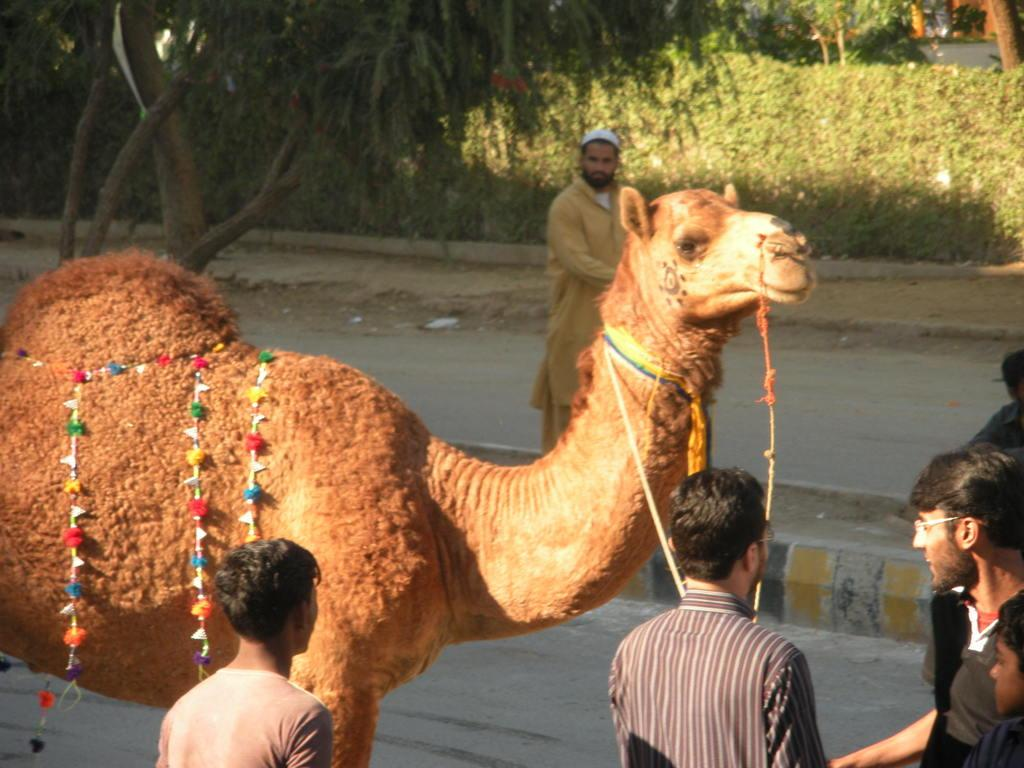What animal is present in the image? There is a camel in the image. What color is the camel? The camel is brown. Who else is in the image besides the camel? There is a group of people in the image. What can be observed about the people's clothing? The people are wearing different color dresses. What can be seen in the background of the image? There are many trees in the background of the image. What type of waste is being recycled by the camel in the image? There is no waste or recycling depicted in the image; it features a camel and a group of people. What kind of vest is the camel wearing in the image? Camels do not wear vests, and there is no vest present in the image. 